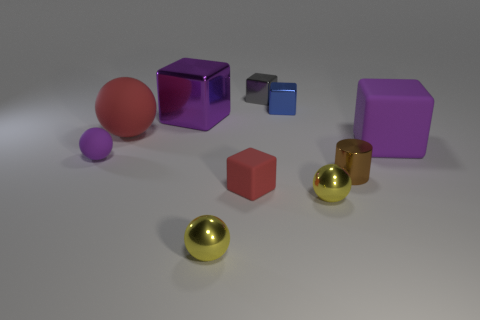Are there any other things that are the same shape as the brown object?
Offer a very short reply. No. There is another big block that is the same color as the big rubber cube; what is it made of?
Your answer should be very brief. Metal. How many blue things are either metallic spheres or large blocks?
Make the answer very short. 0. There is a tiny ball that is on the left side of the tiny blue cube and in front of the brown thing; what color is it?
Ensure brevity in your answer.  Yellow. How many large things are gray shiny blocks or red rubber spheres?
Ensure brevity in your answer.  1. There is a purple matte object that is the same shape as the small gray metal object; what size is it?
Give a very brief answer. Large. The small purple thing has what shape?
Offer a very short reply. Sphere. Does the small brown cylinder have the same material as the large object that is on the right side of the purple metallic thing?
Your response must be concise. No. What number of shiny objects are cyan objects or small spheres?
Your answer should be compact. 2. There is a purple cube that is left of the metal cylinder; what size is it?
Provide a succinct answer. Large. 